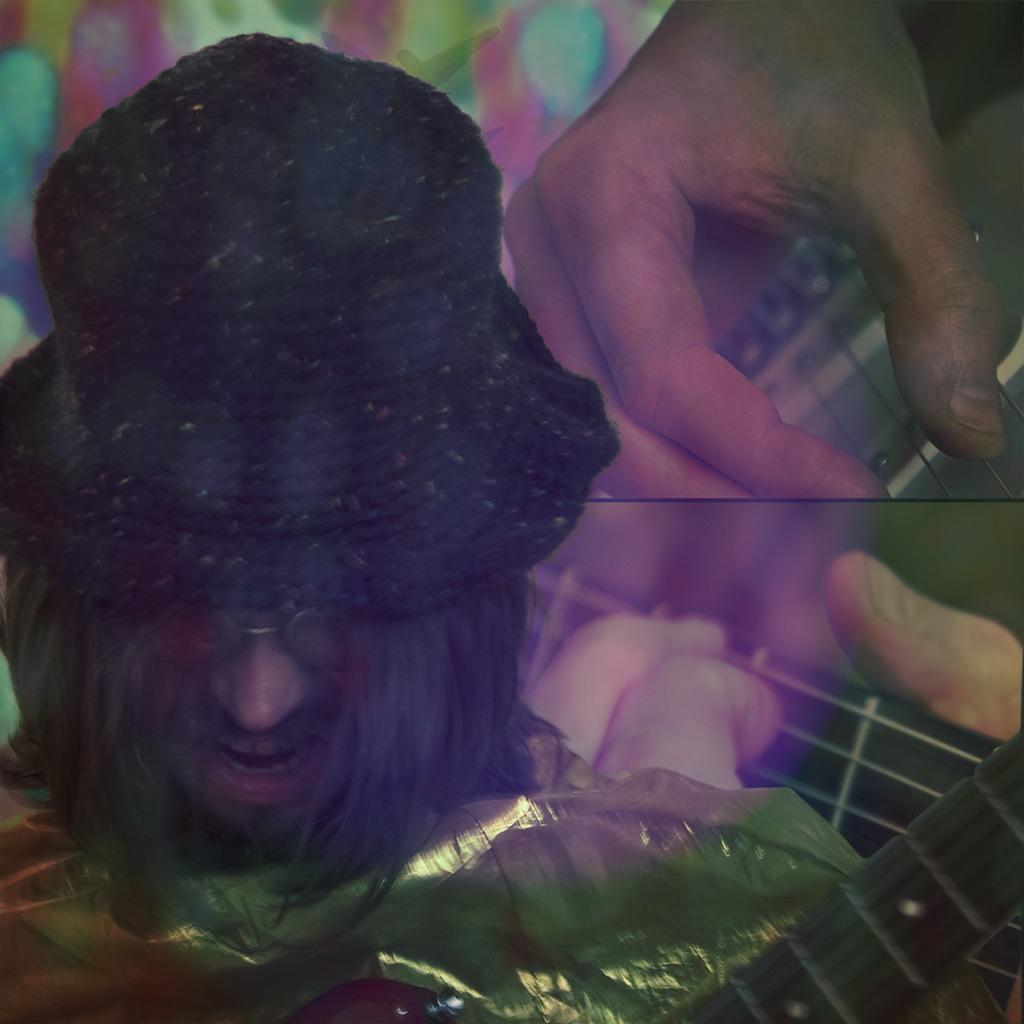What can be said about the nature of the image? The image is edited. What is present on top of the guitars in the image? There is a cover in the image. What musical instruments are visible in the image? There are guitars in the image. Whose hands can be seen in the image? Persons' hands are visible in the image. What accessory is worn by one of the men in the image? A man is wearing a spectacle in the glass in the image. What type of headwear is worn by another man in the image? A man is wearing a cap in the image. What month is depicted in the image? There is no specific month depicted in the image; it is a still image of people with guitars and accessories. What type of brass instrument can be seen in the image? There are no brass instruments present in the image; only guitars are visible. 